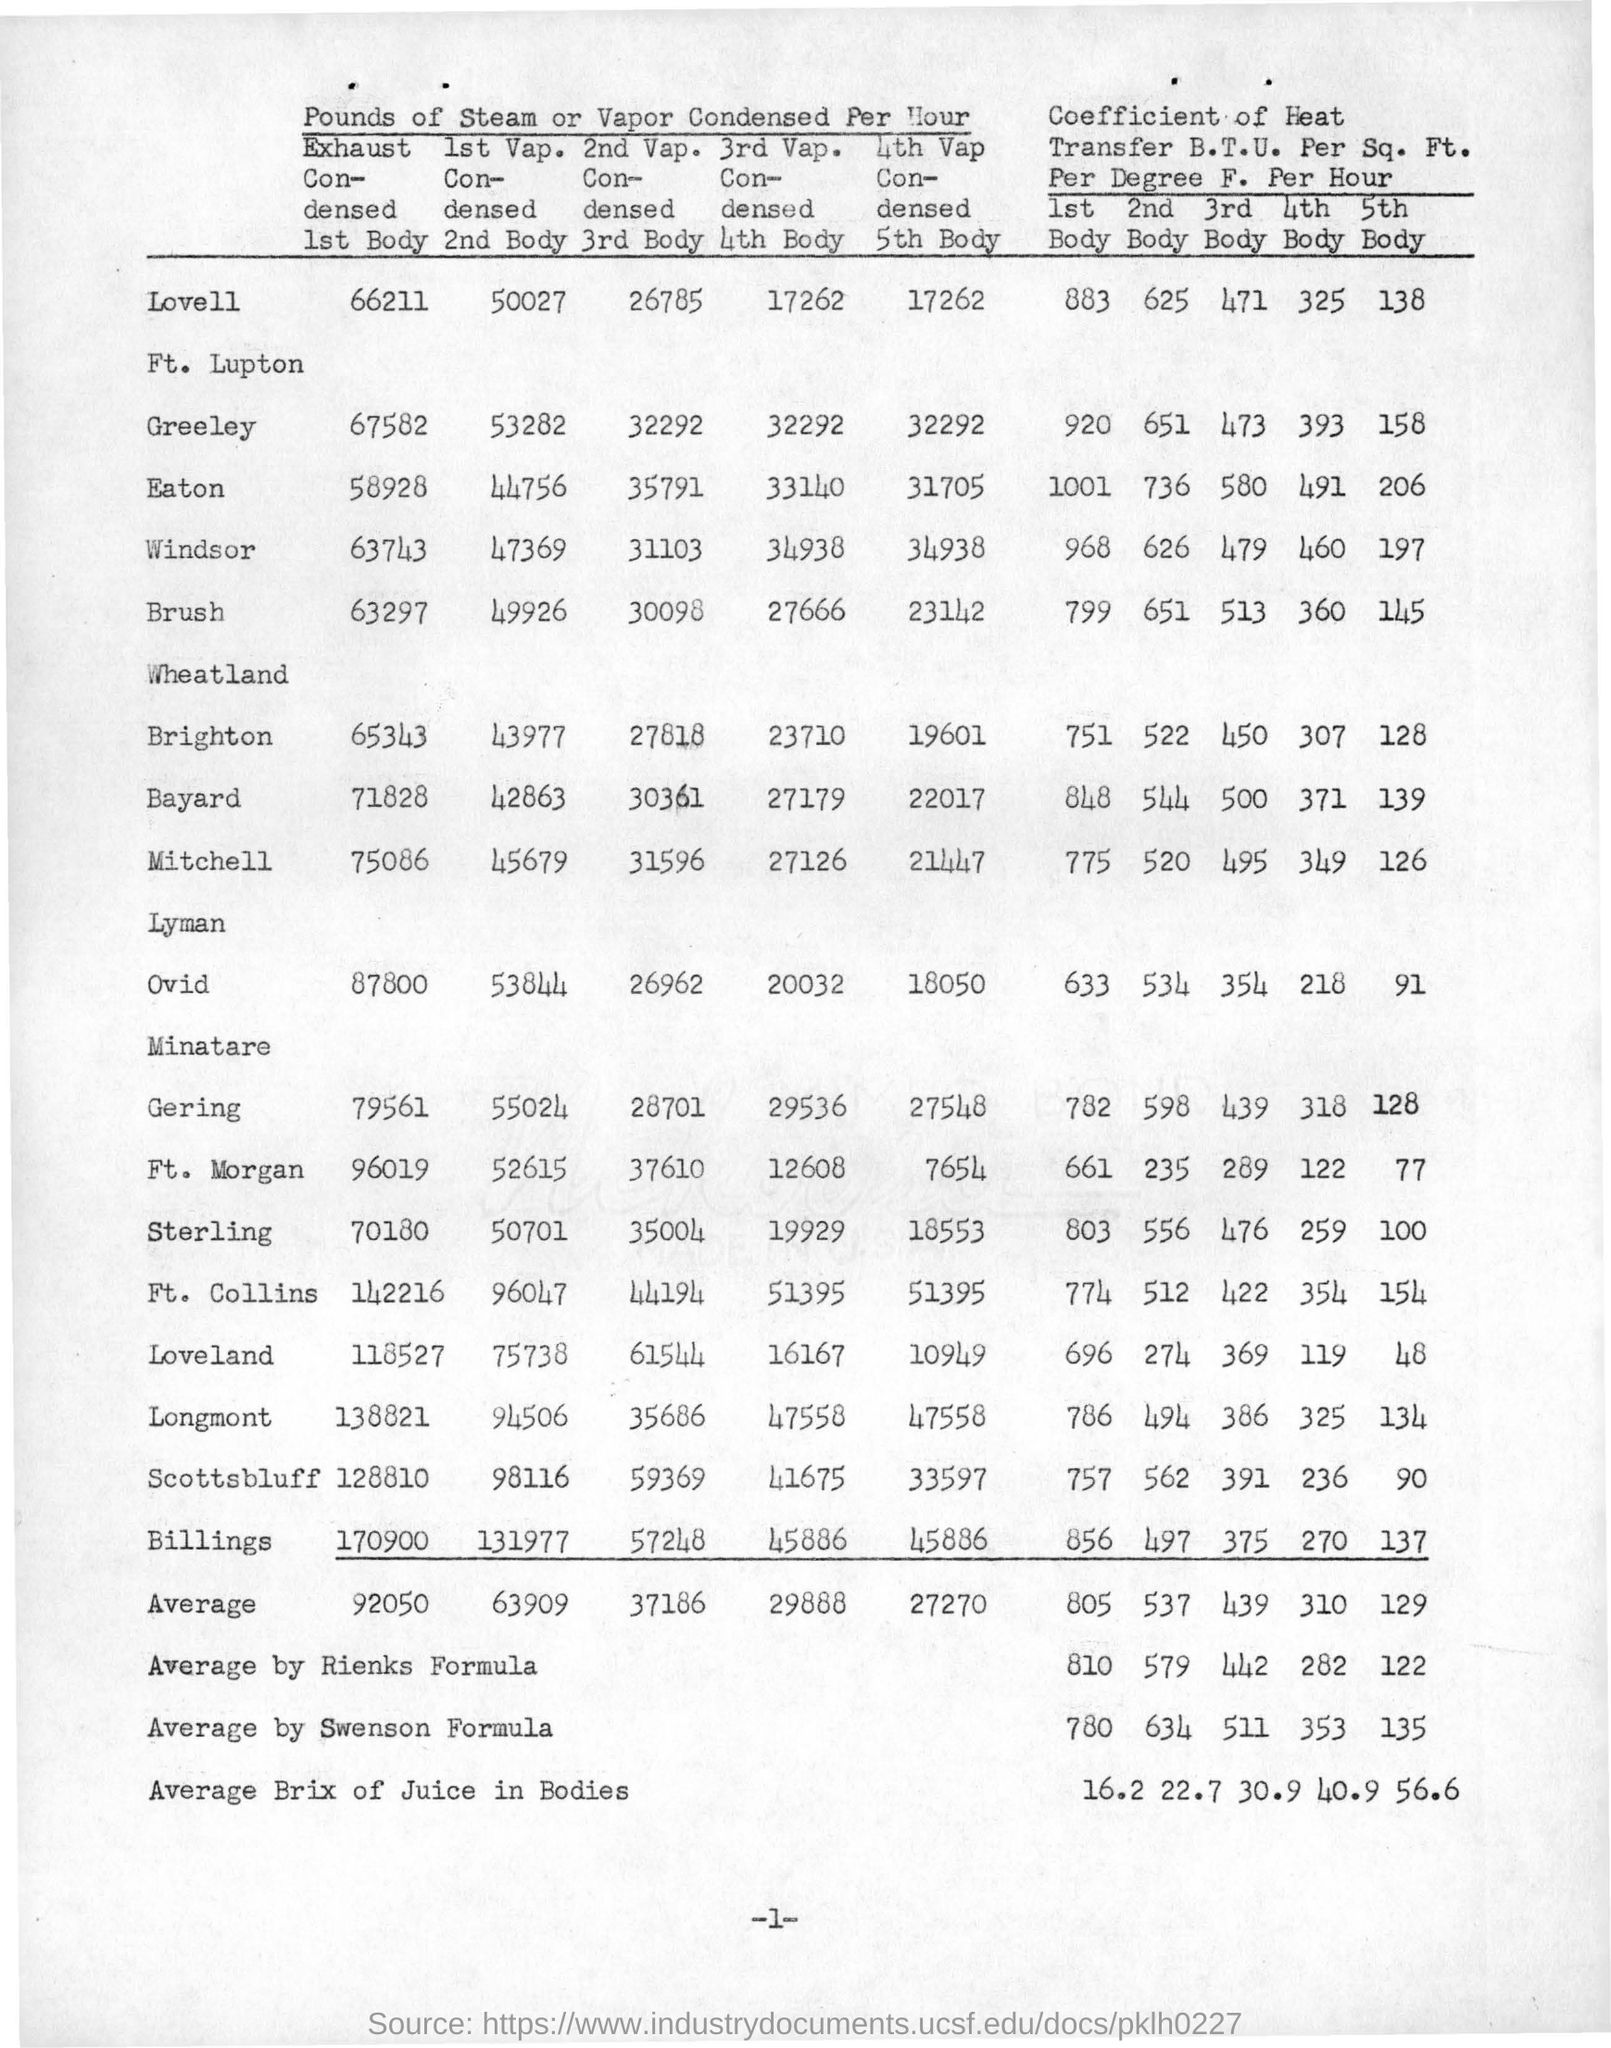What implications might these values have for the process engineering or operational efficiency? The values represented in the table are critical for process engineering as they help to evaluate the efficiency of heat transfer within the condensing system. Higher coefficients indicate more effective heat transfer, which is desirable in most industrial processes for energy conservation and cost reduction. By analyzing these values, engineers can identify which bodies are performing optimally and which may need adjustments or redesigns. Additionally, the data can inform maintenance schedules, as lower coefficients might signal fouling or other performance issues. Furthermore, understanding these coefficients is vital for designing systems with adequate capacity and for optimizing the use of heat exchange surfaces. 